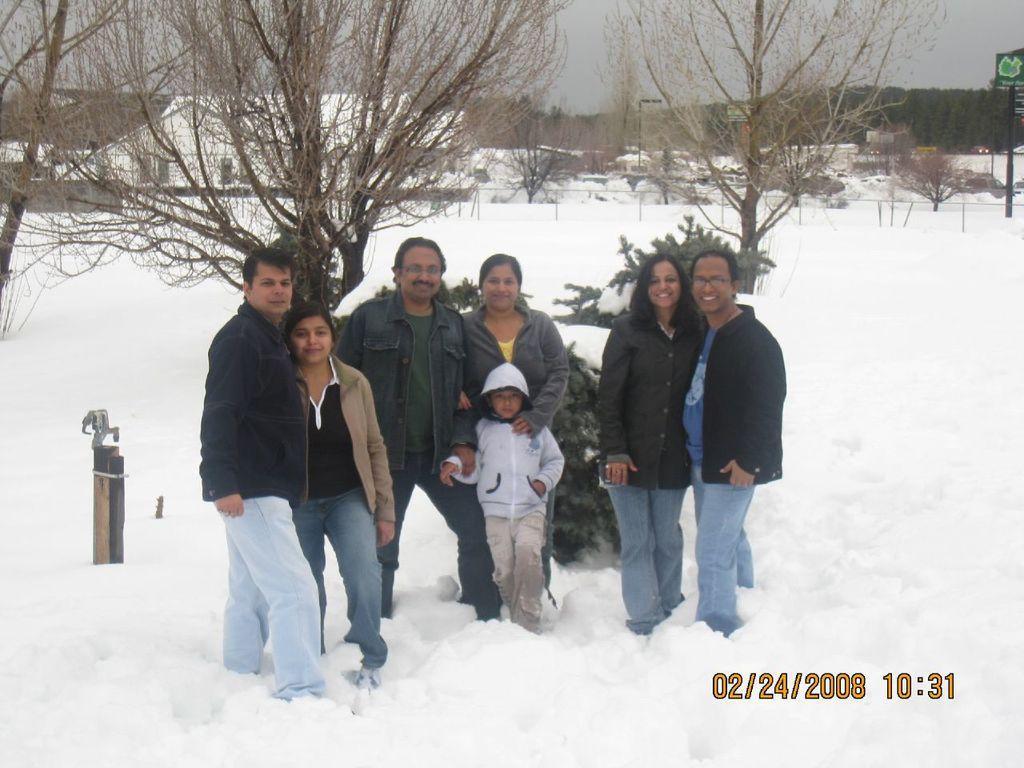In one or two sentences, can you explain what this image depicts? In this image there are few people visible on the snow land, behind them there are some trees, buildings, sky, signboard visible. 